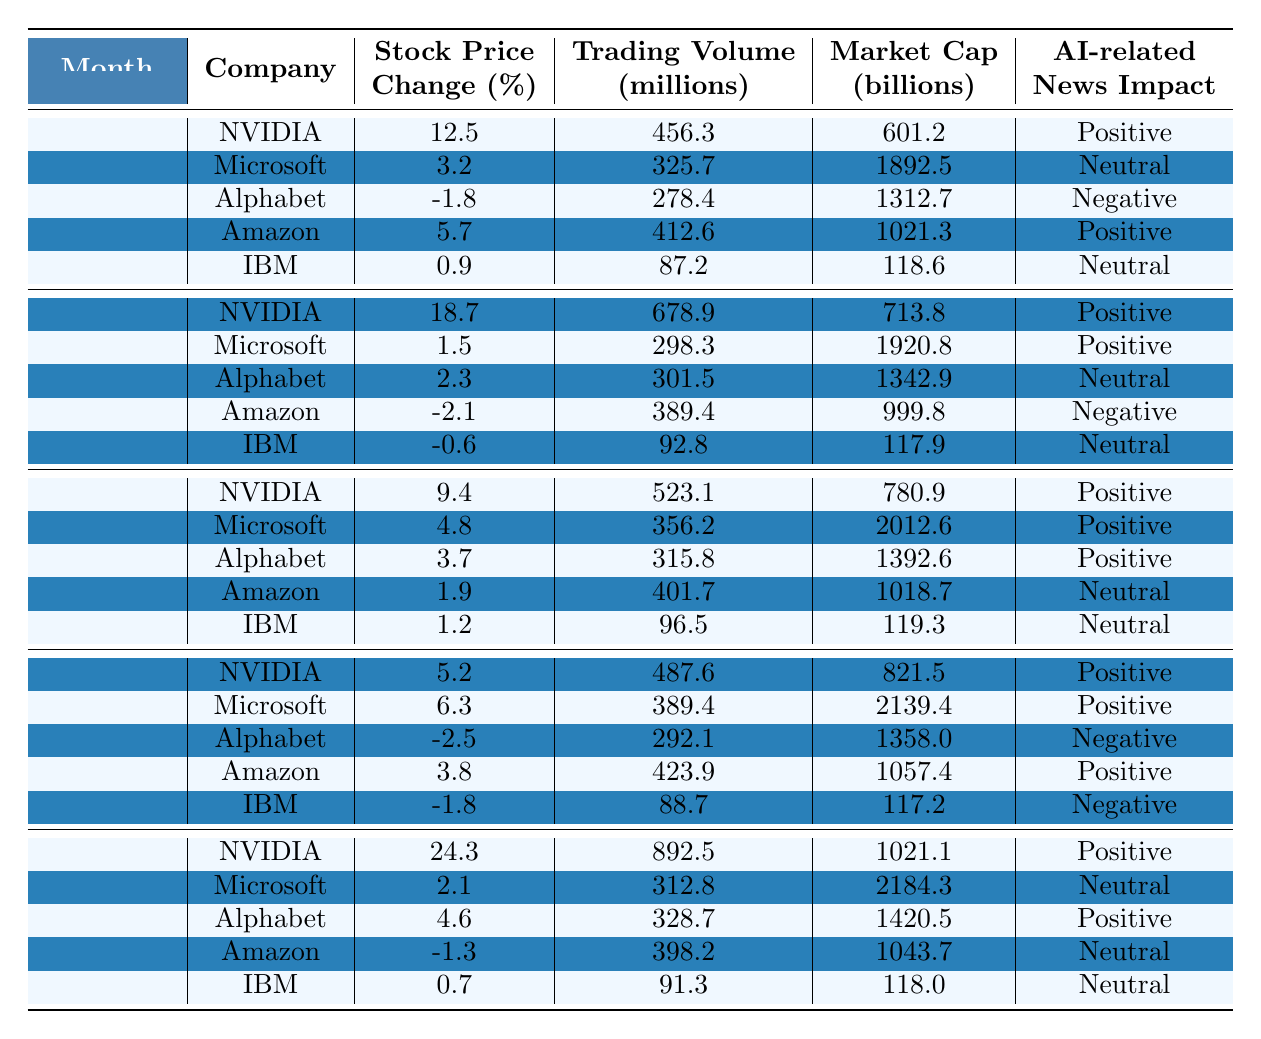What was the highest stock price change percentage for any of the companies in May? In May, NVIDIA had the highest stock price change of 24.3%. By checking the values listed for May, we can see that no other company had a stock price change percentage exceeding this amount.
Answer: 24.3% Which company experienced the largest negative stock price change in April? In April, Alphabet experienced the largest negative stock price change of -2.5%. This can be found by comparing the stock price changes of all companies for April.
Answer: -2.5% What was the average stock price change percentage for Amazon over the five months? The stock price changes for Amazon are 5.7, -2.1, 1.9, 3.8, and -1.3. Summing these values gives 5.7 - 2.1 + 1.9 + 3.8 - 1.3 = 8.0. The average is 8.0 / 5 = 1.6.
Answer: 1.6% Did IBM have a positive impact from AI-related news in any of the months? IBM had a neutral news impact in January, February, March, and May, and a negative impact in April. Therefore, IBM did not experience a positive impact from AI-related news at any time during these months.
Answer: No Which company consistently had a positive stock price change every month from January to May? By reviewing the table, it can be seen that NVIDIA had a positive stock price change every month from January (12.5%) to May (24.3%). This consistency indicates strong performance across all months.
Answer: NVIDIA How does the trading volume of Microsoft in March compare to its trading volume in January? Microsoft's trading volume in March was 356.2 million, while in January it was 325.7 million. Therefore, March's trading volume was higher by 356.2 - 325.7 = 30.5 million.
Answer: 30.5 million What was the total market cap of Alphabet from January to May? The market caps for Alphabet over the months are 1312.7 (January), 1342.9 (February), 1392.6 (March), 1358.0 (April), and 1420.5 (May). Summing these gives 1312.7 + 1342.9 + 1392.6 + 1358.0 + 1420.5 = 5826.7 billion.
Answer: 5826.7 billion Which month had the highest stock price change for NVIDIA and what was the percentage? The highest stock price change for NVIDIA occurred in May at 24.3%. We can observe this by reviewing the stock change percentages month-by-month for NVIDIA.
Answer: May, 24.3% Has Amazon's stock price change percentage ever been positive? Yes, Amazon's stock price change percentage was positive in January (5.7%), March (1.9%), and April (3.8%). Thus, it has had positive changes in multiple months.
Answer: Yes Which company had the lowest trading volume in January? In January, IBM had the lowest trading volume of 87.2 million compared to the other companies listed for that month. Referencing the trading volumes, IBM's value is the smallest.
Answer: 87.2 million 